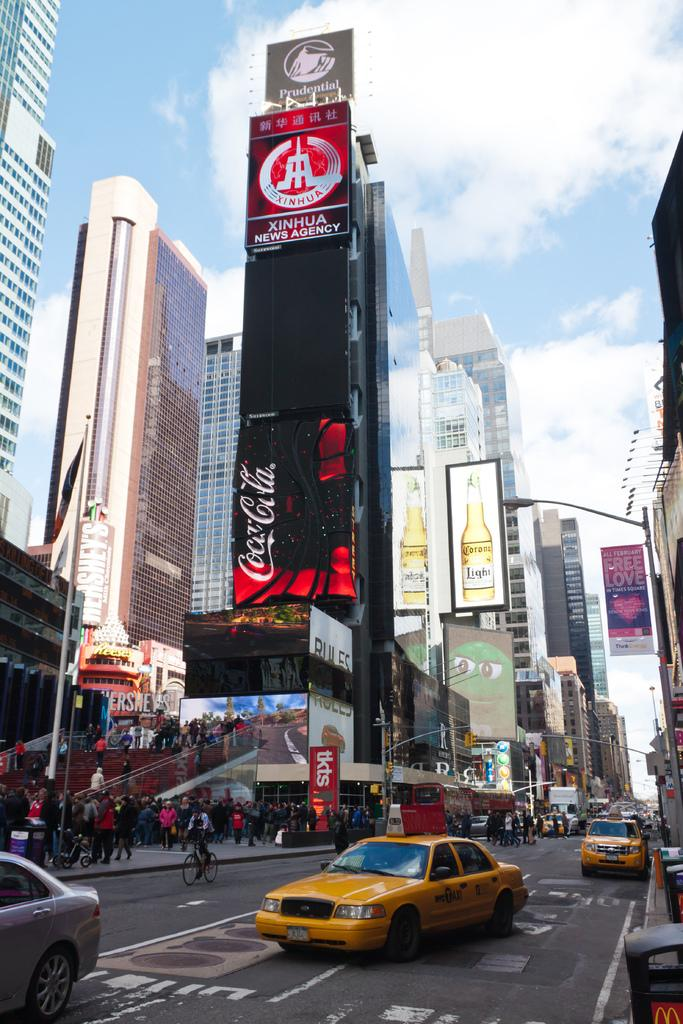<image>
Share a concise interpretation of the image provided. Prudential is one of the companies advertising on the screen. 